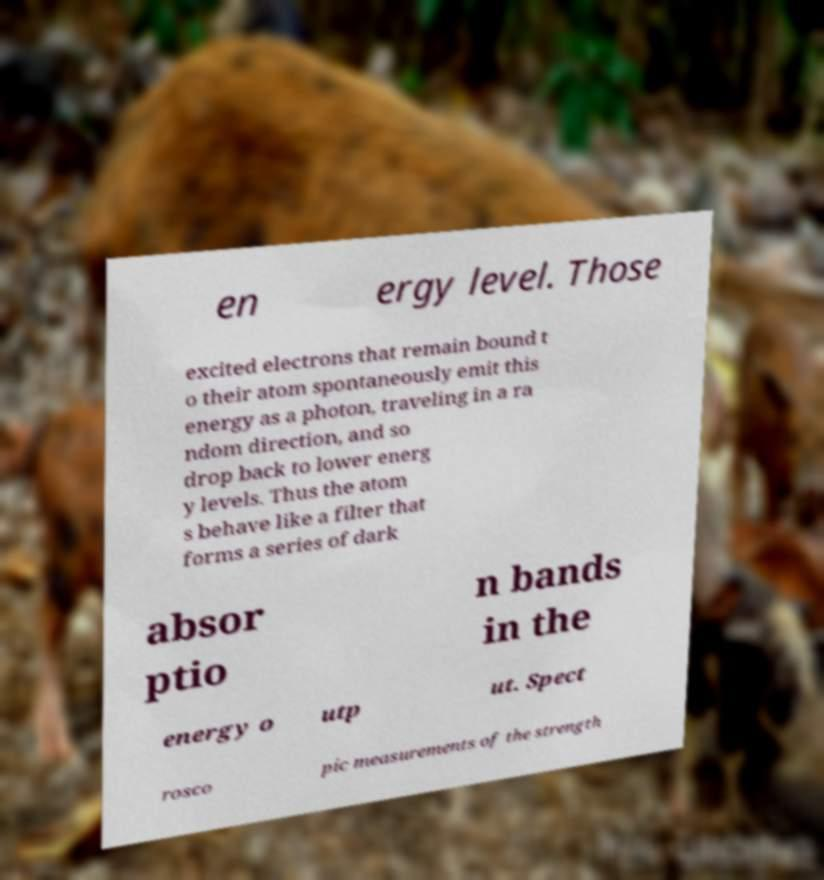For documentation purposes, I need the text within this image transcribed. Could you provide that? en ergy level. Those excited electrons that remain bound t o their atom spontaneously emit this energy as a photon, traveling in a ra ndom direction, and so drop back to lower energ y levels. Thus the atom s behave like a filter that forms a series of dark absor ptio n bands in the energy o utp ut. Spect rosco pic measurements of the strength 